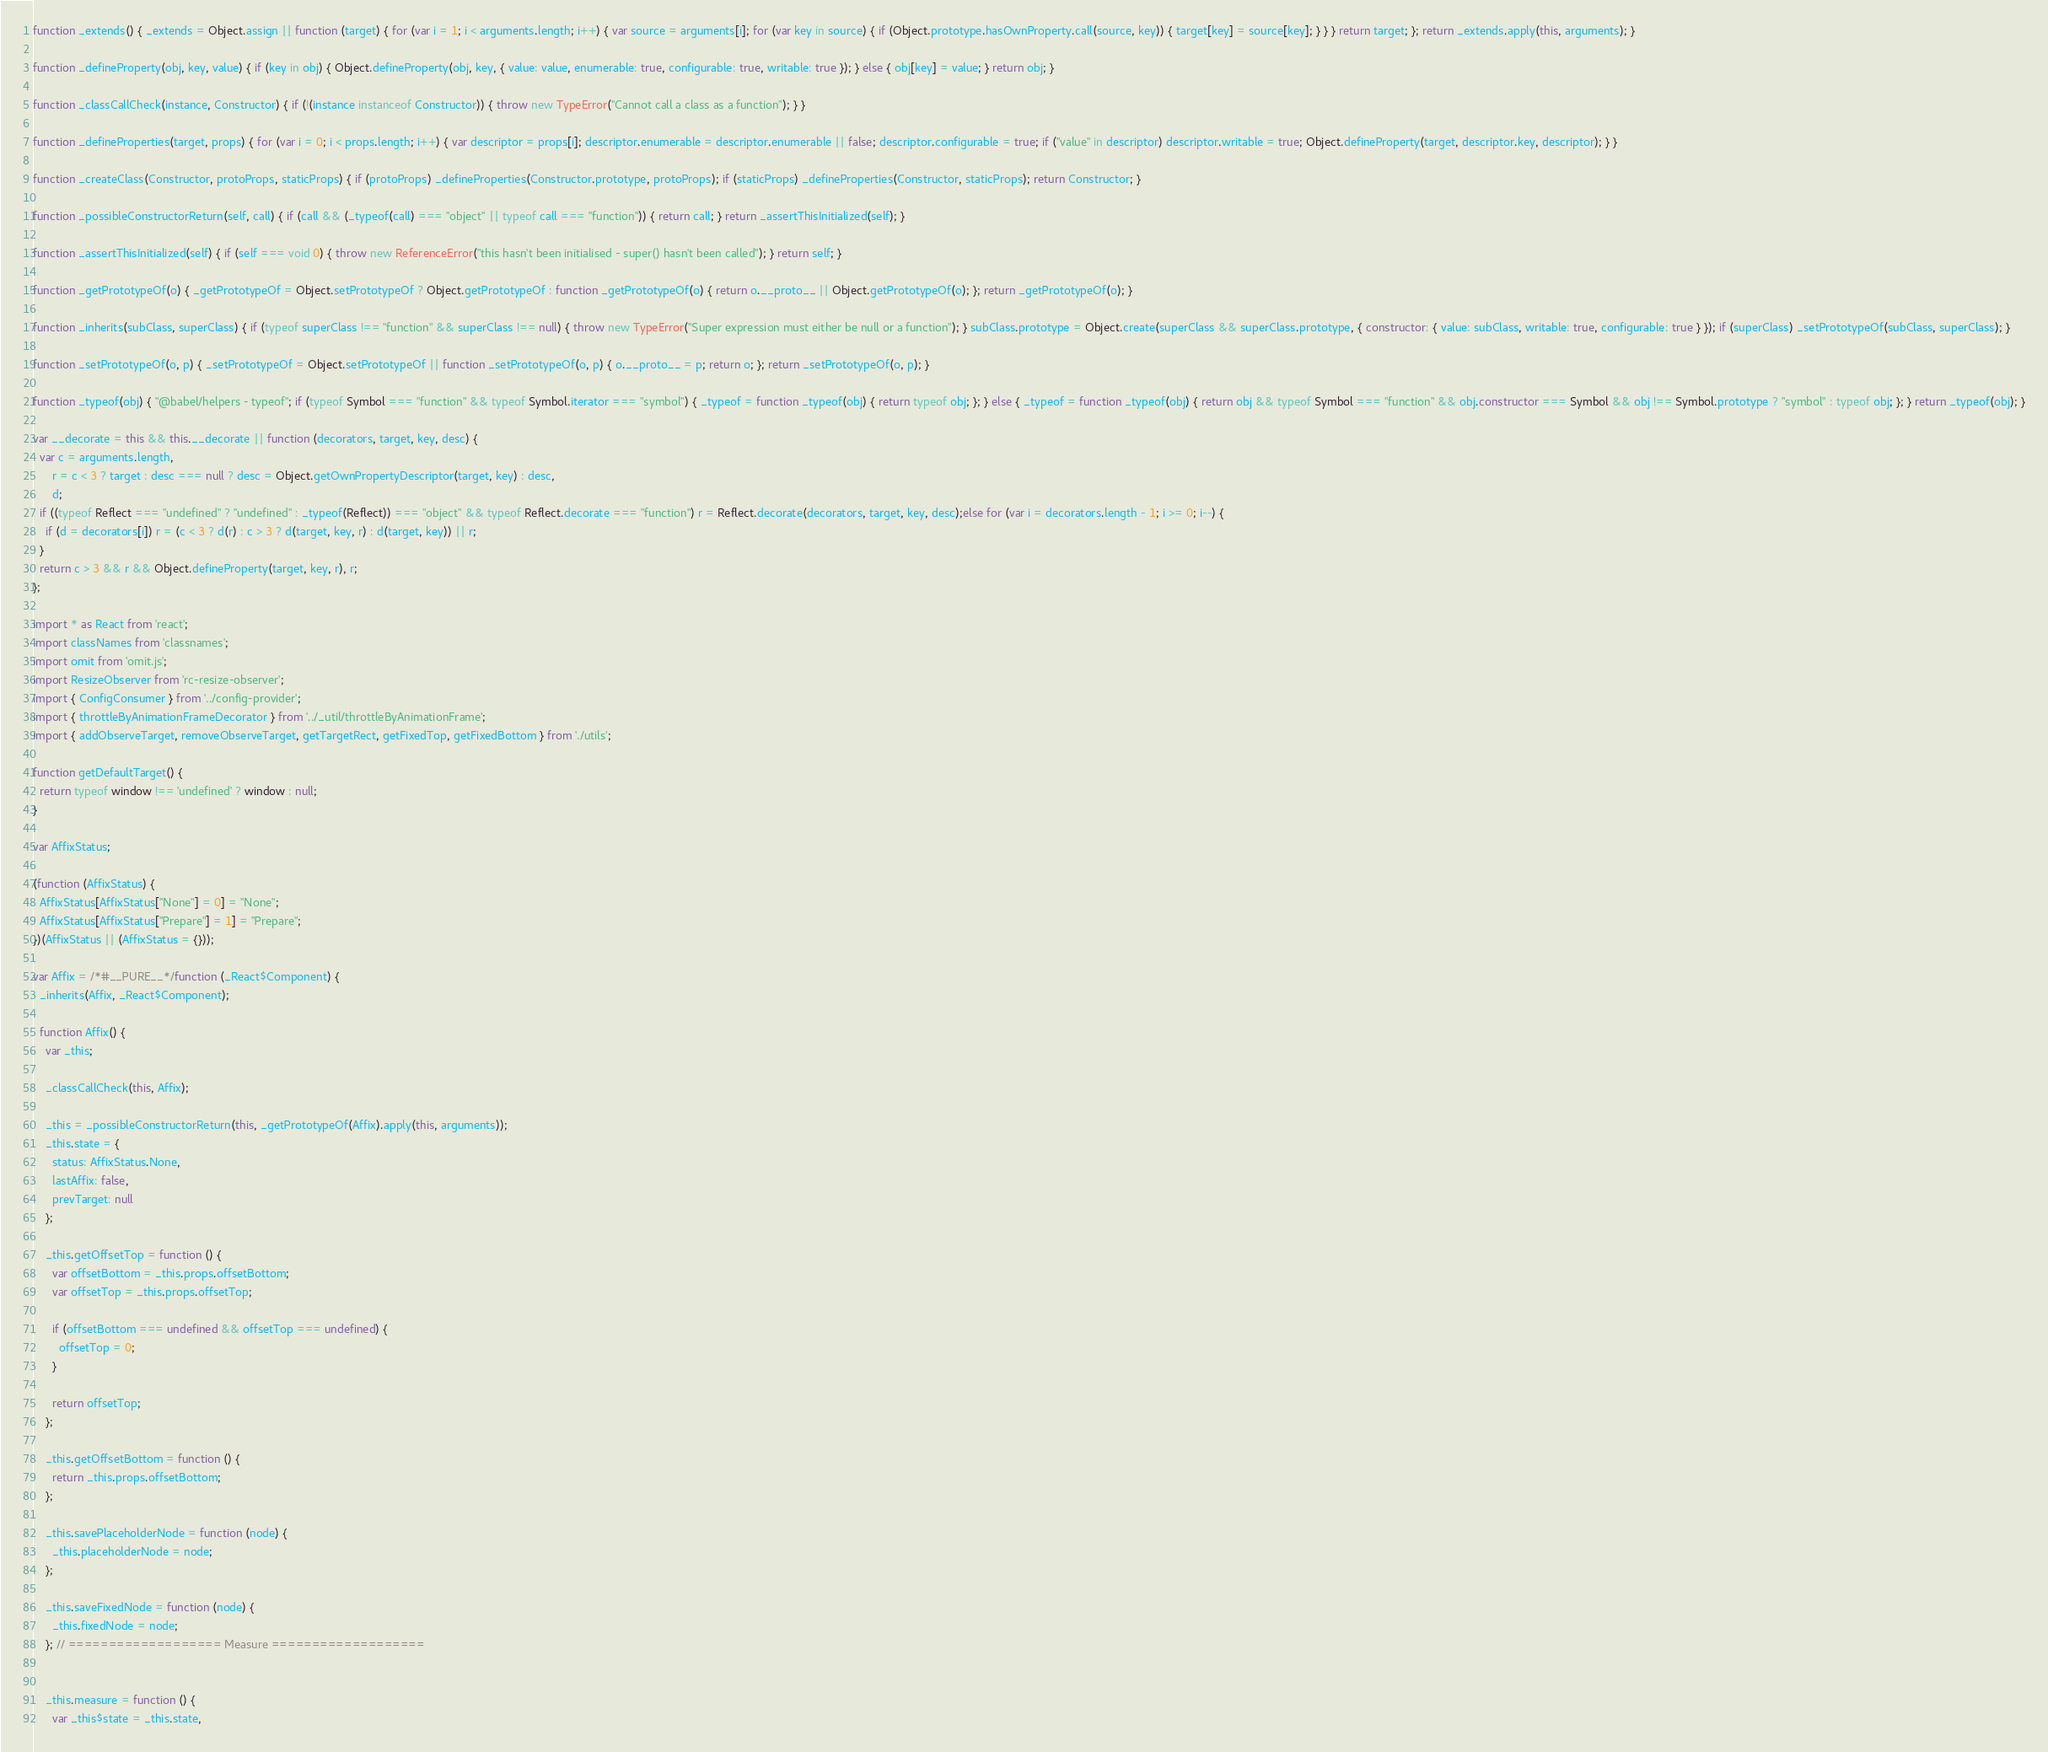<code> <loc_0><loc_0><loc_500><loc_500><_JavaScript_>function _extends() { _extends = Object.assign || function (target) { for (var i = 1; i < arguments.length; i++) { var source = arguments[i]; for (var key in source) { if (Object.prototype.hasOwnProperty.call(source, key)) { target[key] = source[key]; } } } return target; }; return _extends.apply(this, arguments); }

function _defineProperty(obj, key, value) { if (key in obj) { Object.defineProperty(obj, key, { value: value, enumerable: true, configurable: true, writable: true }); } else { obj[key] = value; } return obj; }

function _classCallCheck(instance, Constructor) { if (!(instance instanceof Constructor)) { throw new TypeError("Cannot call a class as a function"); } }

function _defineProperties(target, props) { for (var i = 0; i < props.length; i++) { var descriptor = props[i]; descriptor.enumerable = descriptor.enumerable || false; descriptor.configurable = true; if ("value" in descriptor) descriptor.writable = true; Object.defineProperty(target, descriptor.key, descriptor); } }

function _createClass(Constructor, protoProps, staticProps) { if (protoProps) _defineProperties(Constructor.prototype, protoProps); if (staticProps) _defineProperties(Constructor, staticProps); return Constructor; }

function _possibleConstructorReturn(self, call) { if (call && (_typeof(call) === "object" || typeof call === "function")) { return call; } return _assertThisInitialized(self); }

function _assertThisInitialized(self) { if (self === void 0) { throw new ReferenceError("this hasn't been initialised - super() hasn't been called"); } return self; }

function _getPrototypeOf(o) { _getPrototypeOf = Object.setPrototypeOf ? Object.getPrototypeOf : function _getPrototypeOf(o) { return o.__proto__ || Object.getPrototypeOf(o); }; return _getPrototypeOf(o); }

function _inherits(subClass, superClass) { if (typeof superClass !== "function" && superClass !== null) { throw new TypeError("Super expression must either be null or a function"); } subClass.prototype = Object.create(superClass && superClass.prototype, { constructor: { value: subClass, writable: true, configurable: true } }); if (superClass) _setPrototypeOf(subClass, superClass); }

function _setPrototypeOf(o, p) { _setPrototypeOf = Object.setPrototypeOf || function _setPrototypeOf(o, p) { o.__proto__ = p; return o; }; return _setPrototypeOf(o, p); }

function _typeof(obj) { "@babel/helpers - typeof"; if (typeof Symbol === "function" && typeof Symbol.iterator === "symbol") { _typeof = function _typeof(obj) { return typeof obj; }; } else { _typeof = function _typeof(obj) { return obj && typeof Symbol === "function" && obj.constructor === Symbol && obj !== Symbol.prototype ? "symbol" : typeof obj; }; } return _typeof(obj); }

var __decorate = this && this.__decorate || function (decorators, target, key, desc) {
  var c = arguments.length,
      r = c < 3 ? target : desc === null ? desc = Object.getOwnPropertyDescriptor(target, key) : desc,
      d;
  if ((typeof Reflect === "undefined" ? "undefined" : _typeof(Reflect)) === "object" && typeof Reflect.decorate === "function") r = Reflect.decorate(decorators, target, key, desc);else for (var i = decorators.length - 1; i >= 0; i--) {
    if (d = decorators[i]) r = (c < 3 ? d(r) : c > 3 ? d(target, key, r) : d(target, key)) || r;
  }
  return c > 3 && r && Object.defineProperty(target, key, r), r;
};

import * as React from 'react';
import classNames from 'classnames';
import omit from 'omit.js';
import ResizeObserver from 'rc-resize-observer';
import { ConfigConsumer } from '../config-provider';
import { throttleByAnimationFrameDecorator } from '../_util/throttleByAnimationFrame';
import { addObserveTarget, removeObserveTarget, getTargetRect, getFixedTop, getFixedBottom } from './utils';

function getDefaultTarget() {
  return typeof window !== 'undefined' ? window : null;
}

var AffixStatus;

(function (AffixStatus) {
  AffixStatus[AffixStatus["None"] = 0] = "None";
  AffixStatus[AffixStatus["Prepare"] = 1] = "Prepare";
})(AffixStatus || (AffixStatus = {}));

var Affix = /*#__PURE__*/function (_React$Component) {
  _inherits(Affix, _React$Component);

  function Affix() {
    var _this;

    _classCallCheck(this, Affix);

    _this = _possibleConstructorReturn(this, _getPrototypeOf(Affix).apply(this, arguments));
    _this.state = {
      status: AffixStatus.None,
      lastAffix: false,
      prevTarget: null
    };

    _this.getOffsetTop = function () {
      var offsetBottom = _this.props.offsetBottom;
      var offsetTop = _this.props.offsetTop;

      if (offsetBottom === undefined && offsetTop === undefined) {
        offsetTop = 0;
      }

      return offsetTop;
    };

    _this.getOffsetBottom = function () {
      return _this.props.offsetBottom;
    };

    _this.savePlaceholderNode = function (node) {
      _this.placeholderNode = node;
    };

    _this.saveFixedNode = function (node) {
      _this.fixedNode = node;
    }; // =================== Measure ===================


    _this.measure = function () {
      var _this$state = _this.state,</code> 